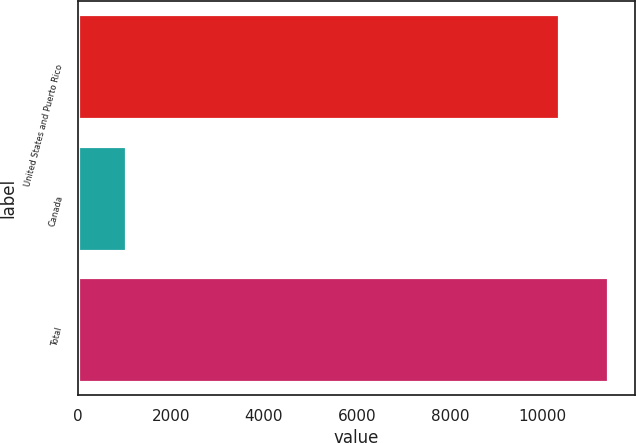<chart> <loc_0><loc_0><loc_500><loc_500><bar_chart><fcel>United States and Puerto Rico<fcel>Canada<fcel>Total<nl><fcel>10355<fcel>1047<fcel>11402<nl></chart> 